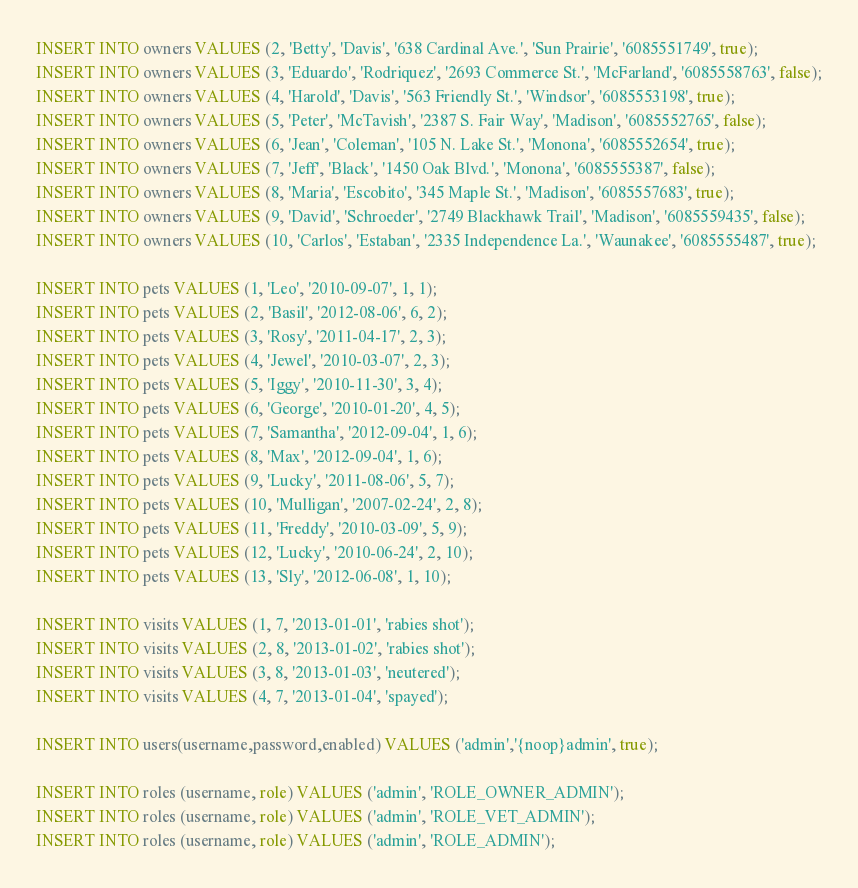Convert code to text. <code><loc_0><loc_0><loc_500><loc_500><_SQL_>INSERT INTO owners VALUES (2, 'Betty', 'Davis', '638 Cardinal Ave.', 'Sun Prairie', '6085551749', true);
INSERT INTO owners VALUES (3, 'Eduardo', 'Rodriquez', '2693 Commerce St.', 'McFarland', '6085558763', false);
INSERT INTO owners VALUES (4, 'Harold', 'Davis', '563 Friendly St.', 'Windsor', '6085553198', true);
INSERT INTO owners VALUES (5, 'Peter', 'McTavish', '2387 S. Fair Way', 'Madison', '6085552765', false);
INSERT INTO owners VALUES (6, 'Jean', 'Coleman', '105 N. Lake St.', 'Monona', '6085552654', true);
INSERT INTO owners VALUES (7, 'Jeff', 'Black', '1450 Oak Blvd.', 'Monona', '6085555387', false);
INSERT INTO owners VALUES (8, 'Maria', 'Escobito', '345 Maple St.', 'Madison', '6085557683', true);
INSERT INTO owners VALUES (9, 'David', 'Schroeder', '2749 Blackhawk Trail', 'Madison', '6085559435', false);
INSERT INTO owners VALUES (10, 'Carlos', 'Estaban', '2335 Independence La.', 'Waunakee', '6085555487', true);

INSERT INTO pets VALUES (1, 'Leo', '2010-09-07', 1, 1);
INSERT INTO pets VALUES (2, 'Basil', '2012-08-06', 6, 2);
INSERT INTO pets VALUES (3, 'Rosy', '2011-04-17', 2, 3);
INSERT INTO pets VALUES (4, 'Jewel', '2010-03-07', 2, 3);
INSERT INTO pets VALUES (5, 'Iggy', '2010-11-30', 3, 4);
INSERT INTO pets VALUES (6, 'George', '2010-01-20', 4, 5);
INSERT INTO pets VALUES (7, 'Samantha', '2012-09-04', 1, 6);
INSERT INTO pets VALUES (8, 'Max', '2012-09-04', 1, 6);
INSERT INTO pets VALUES (9, 'Lucky', '2011-08-06', 5, 7);
INSERT INTO pets VALUES (10, 'Mulligan', '2007-02-24', 2, 8);
INSERT INTO pets VALUES (11, 'Freddy', '2010-03-09', 5, 9);
INSERT INTO pets VALUES (12, 'Lucky', '2010-06-24', 2, 10);
INSERT INTO pets VALUES (13, 'Sly', '2012-06-08', 1, 10);

INSERT INTO visits VALUES (1, 7, '2013-01-01', 'rabies shot');
INSERT INTO visits VALUES (2, 8, '2013-01-02', 'rabies shot');
INSERT INTO visits VALUES (3, 8, '2013-01-03', 'neutered');
INSERT INTO visits VALUES (4, 7, '2013-01-04', 'spayed');

INSERT INTO users(username,password,enabled) VALUES ('admin','{noop}admin', true);

INSERT INTO roles (username, role) VALUES ('admin', 'ROLE_OWNER_ADMIN');
INSERT INTO roles (username, role) VALUES ('admin', 'ROLE_VET_ADMIN');
INSERT INTO roles (username, role) VALUES ('admin', 'ROLE_ADMIN');
</code> 